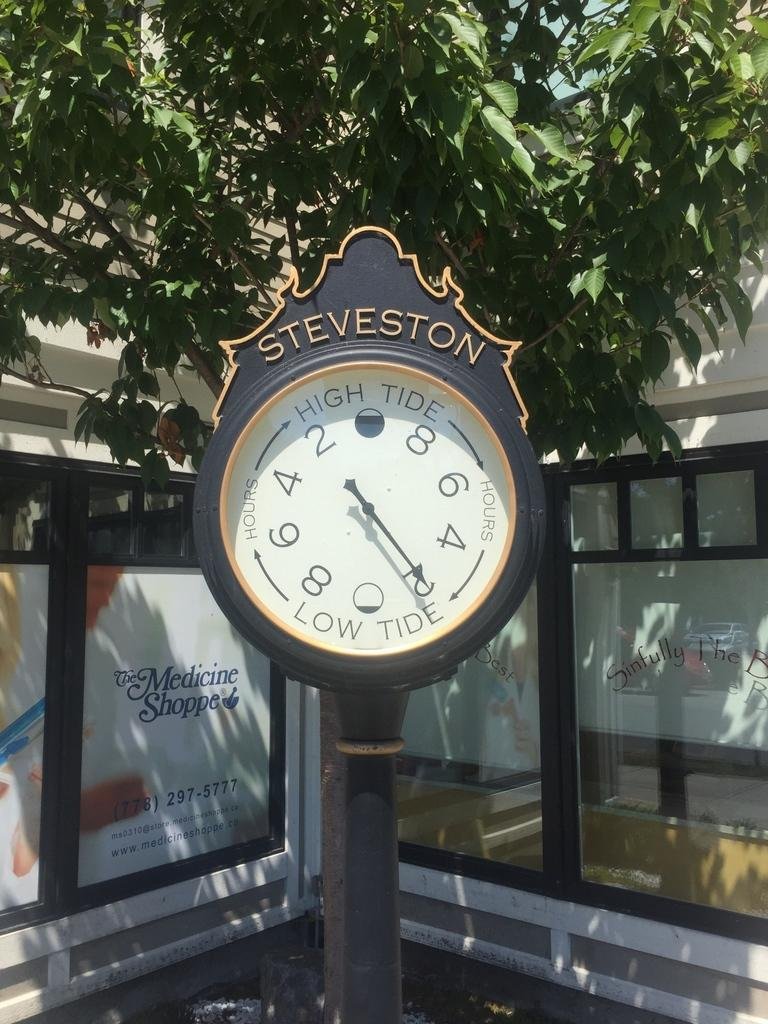<image>
Write a terse but informative summary of the picture. Low tide in Steveston will begin in two hours. 